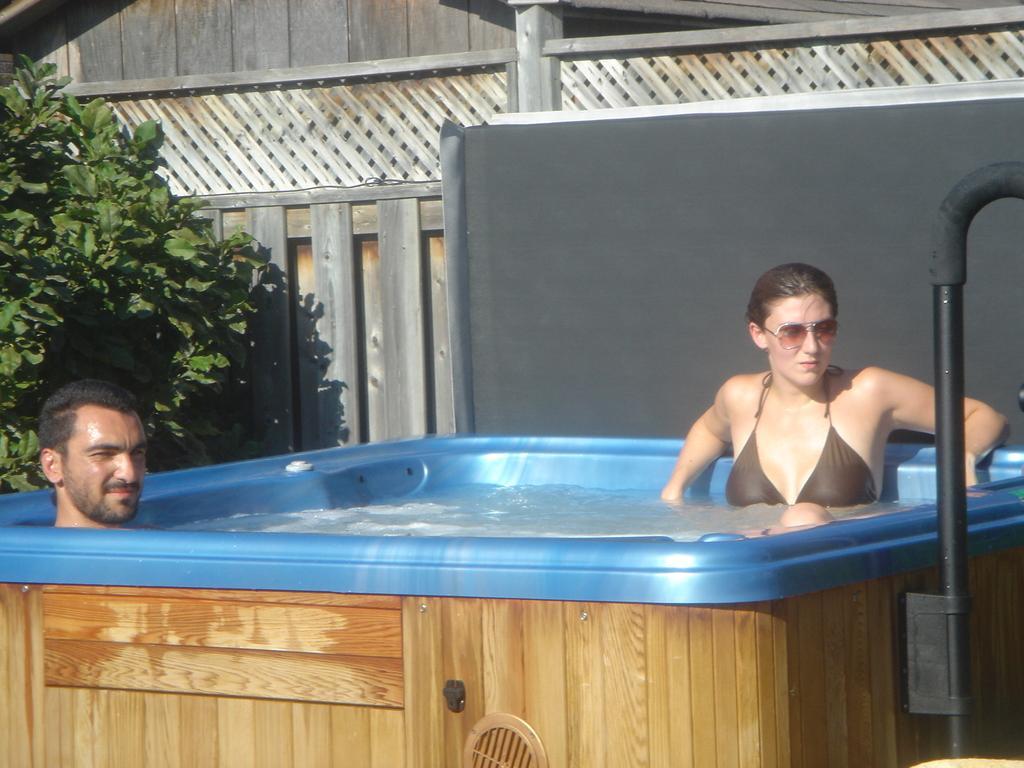In one or two sentences, can you explain what this image depicts? In this image we can see two persons in a water tub and behind them we can see the plants. 